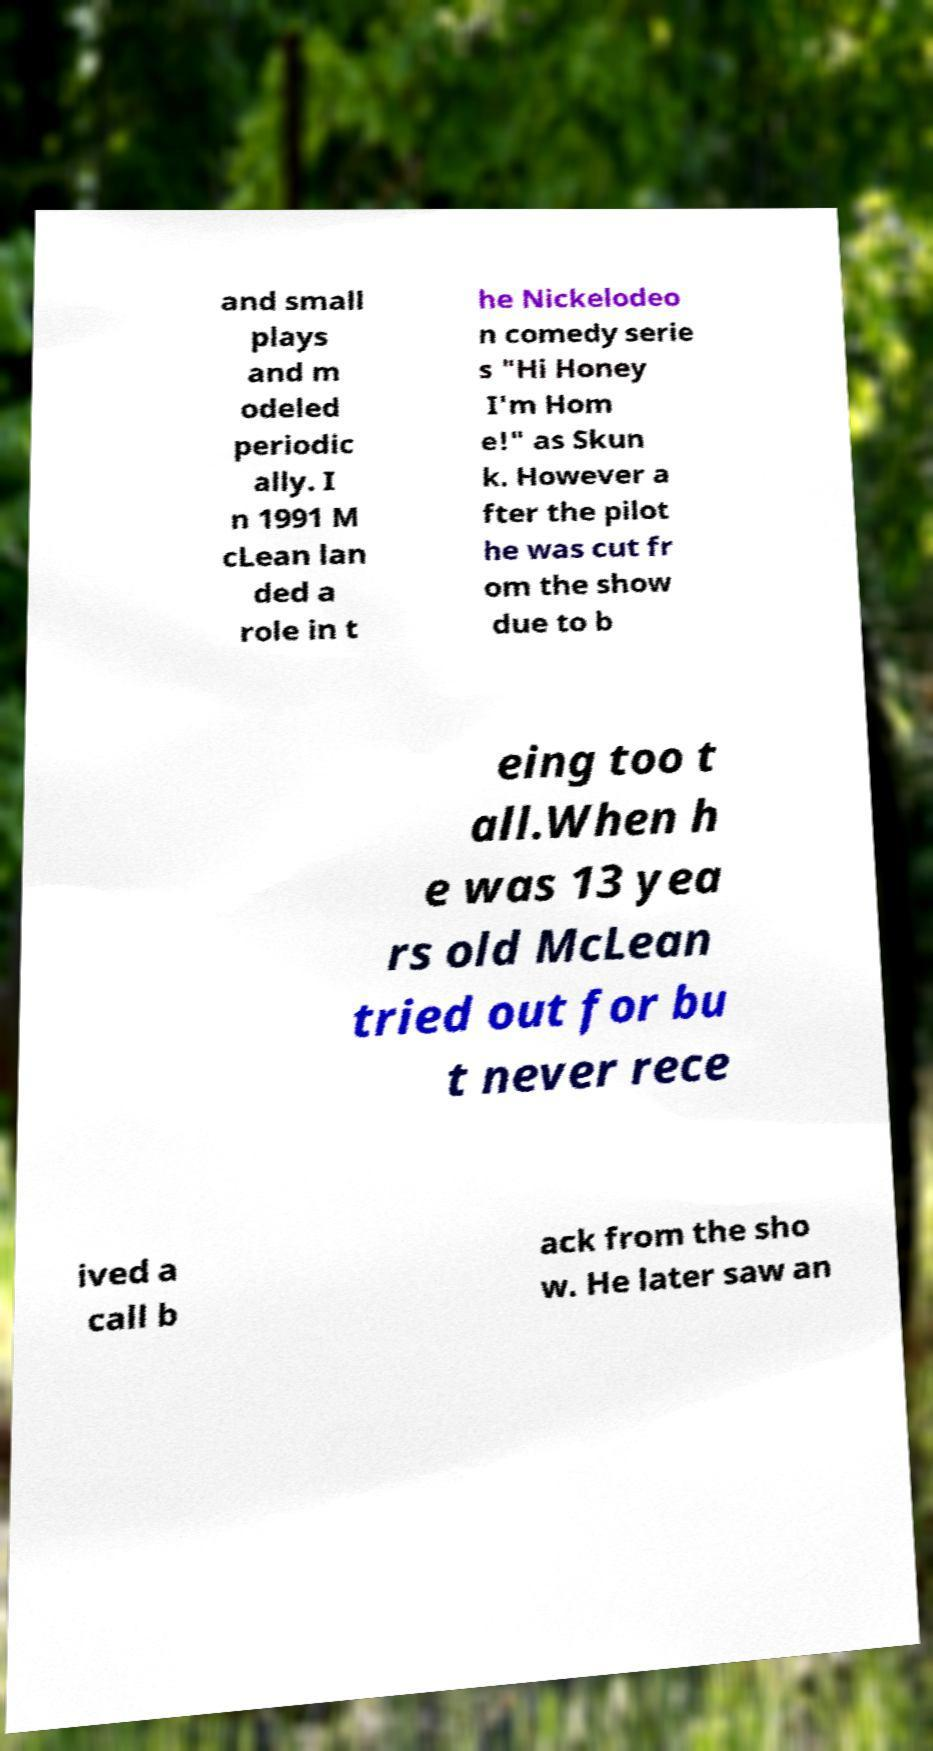Could you extract and type out the text from this image? and small plays and m odeled periodic ally. I n 1991 M cLean lan ded a role in t he Nickelodeo n comedy serie s "Hi Honey I'm Hom e!" as Skun k. However a fter the pilot he was cut fr om the show due to b eing too t all.When h e was 13 yea rs old McLean tried out for bu t never rece ived a call b ack from the sho w. He later saw an 